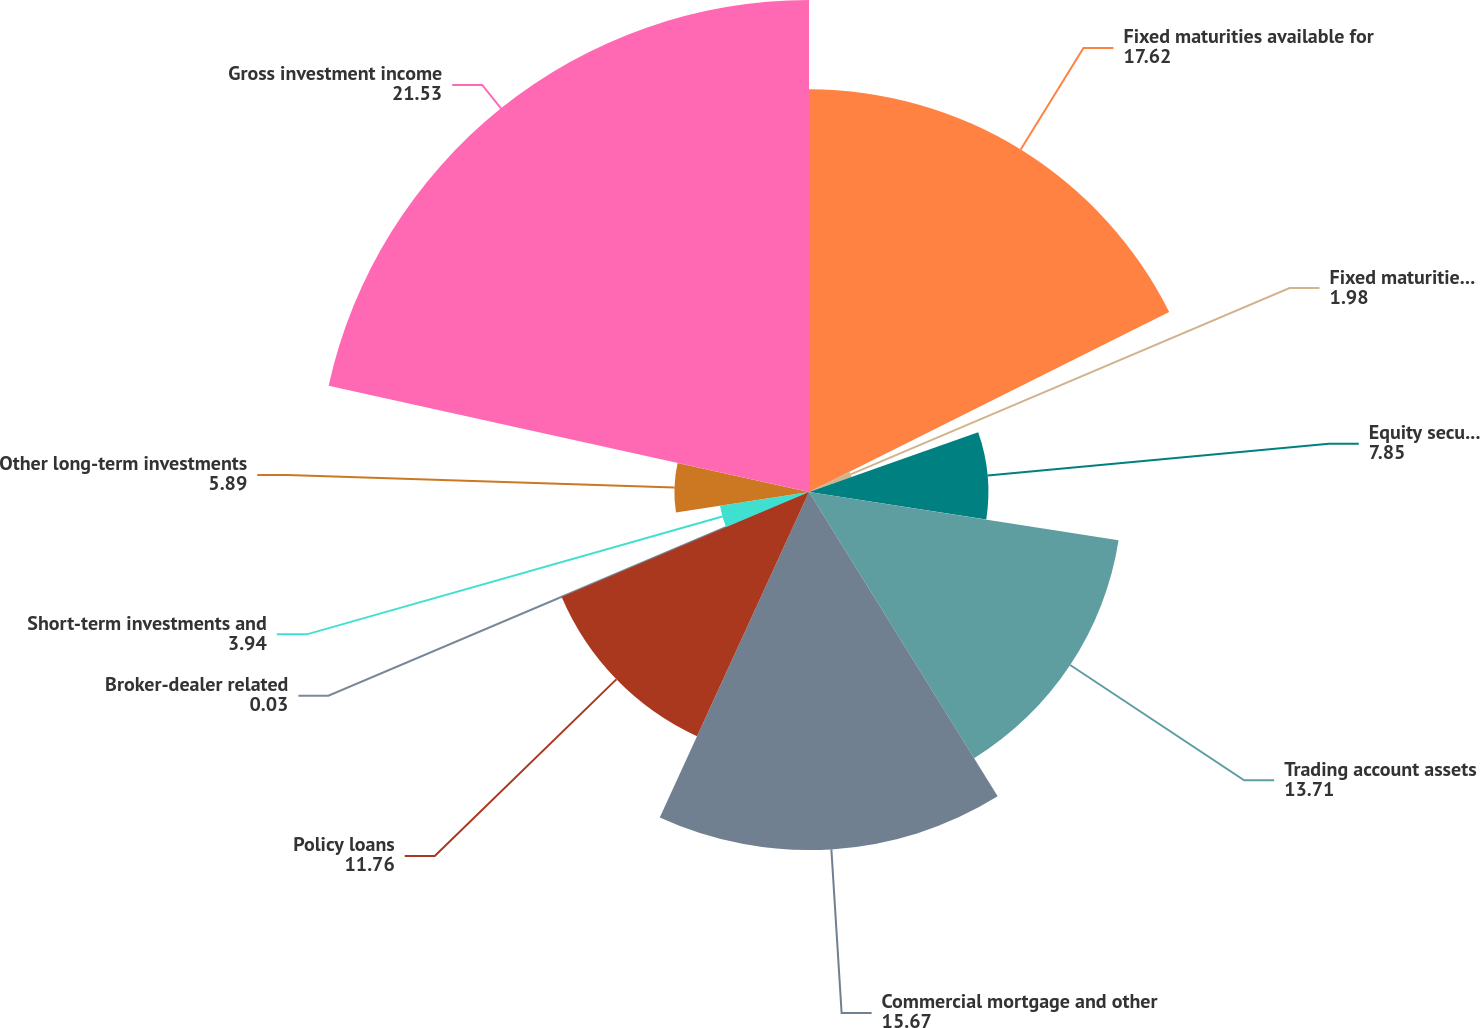<chart> <loc_0><loc_0><loc_500><loc_500><pie_chart><fcel>Fixed maturities available for<fcel>Fixed maturities held to<fcel>Equity securities available<fcel>Trading account assets<fcel>Commercial mortgage and other<fcel>Policy loans<fcel>Broker-dealer related<fcel>Short-term investments and<fcel>Other long-term investments<fcel>Gross investment income<nl><fcel>17.62%<fcel>1.98%<fcel>7.85%<fcel>13.71%<fcel>15.67%<fcel>11.76%<fcel>0.03%<fcel>3.94%<fcel>5.89%<fcel>21.53%<nl></chart> 